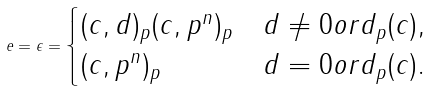Convert formula to latex. <formula><loc_0><loc_0><loc_500><loc_500>e = \epsilon = \begin{cases} ( c , d ) _ { p } ( c , p ^ { n } ) _ { p } & d \neq 0 o r d _ { p } ( c ) , \\ ( c , p ^ { n } ) _ { p } & d = 0 o r d _ { p } ( c ) . \end{cases}</formula> 